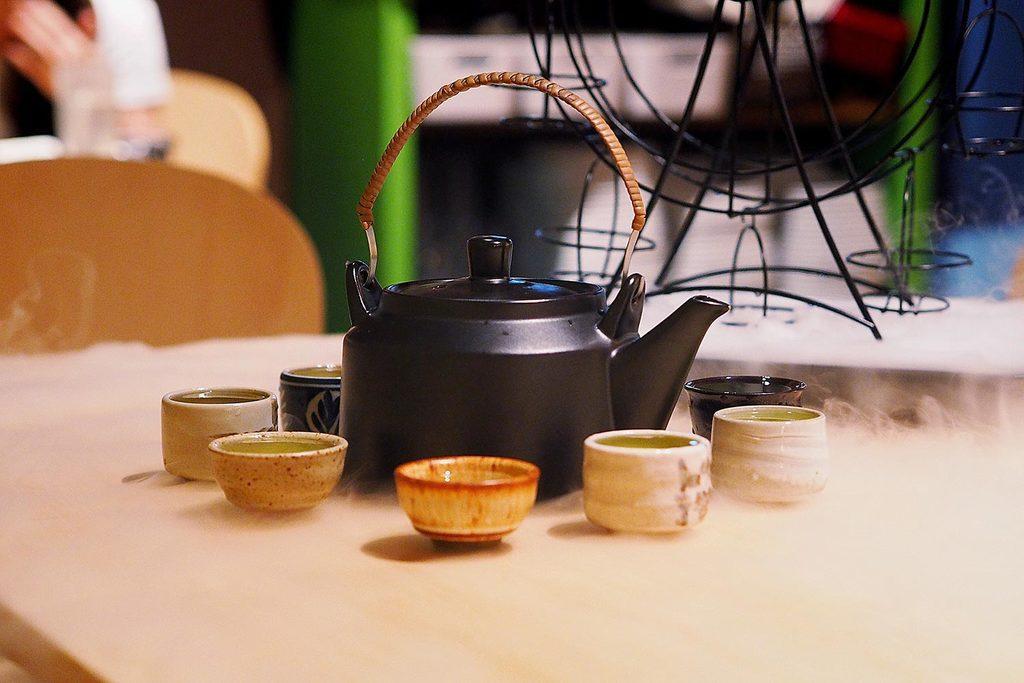Describe this image in one or two sentences. In this image there is a tea jug and some cups on the table beside them there is a stand and some other things. 